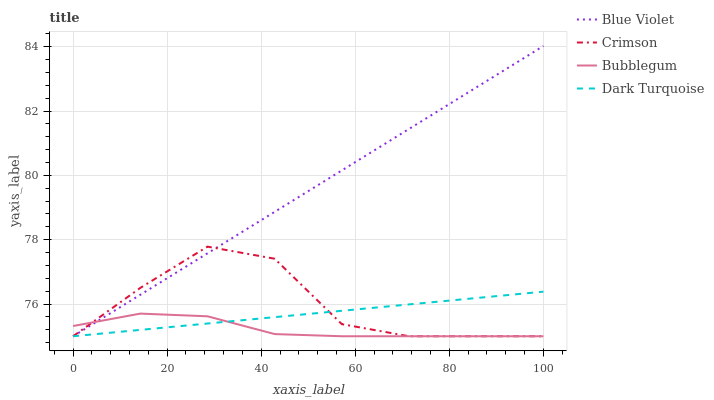Does Bubblegum have the minimum area under the curve?
Answer yes or no. Yes. Does Blue Violet have the maximum area under the curve?
Answer yes or no. Yes. Does Dark Turquoise have the minimum area under the curve?
Answer yes or no. No. Does Dark Turquoise have the maximum area under the curve?
Answer yes or no. No. Is Blue Violet the smoothest?
Answer yes or no. Yes. Is Crimson the roughest?
Answer yes or no. Yes. Is Dark Turquoise the smoothest?
Answer yes or no. No. Is Dark Turquoise the roughest?
Answer yes or no. No. Does Blue Violet have the highest value?
Answer yes or no. Yes. Does Dark Turquoise have the highest value?
Answer yes or no. No. Does Dark Turquoise intersect Blue Violet?
Answer yes or no. Yes. Is Dark Turquoise less than Blue Violet?
Answer yes or no. No. Is Dark Turquoise greater than Blue Violet?
Answer yes or no. No. 